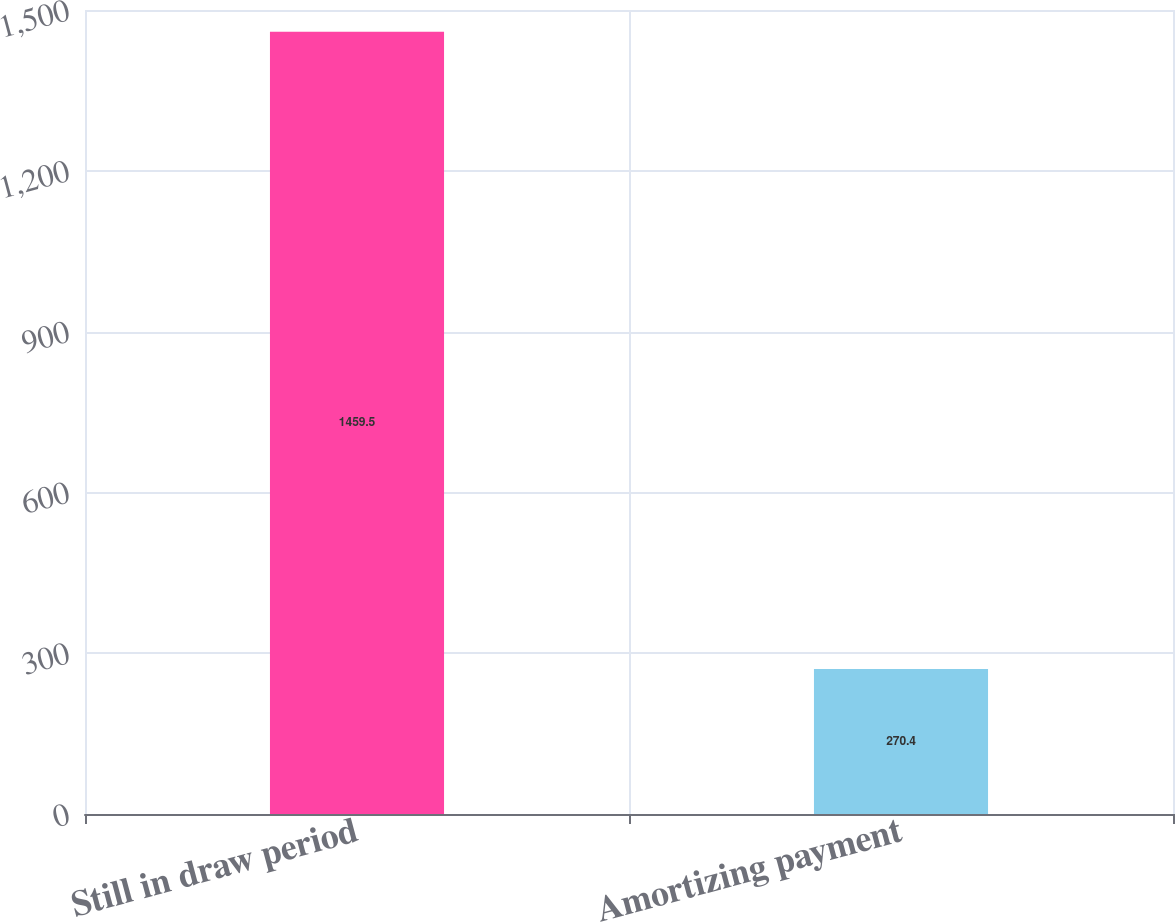Convert chart. <chart><loc_0><loc_0><loc_500><loc_500><bar_chart><fcel>Still in draw period<fcel>Amortizing payment<nl><fcel>1459.5<fcel>270.4<nl></chart> 